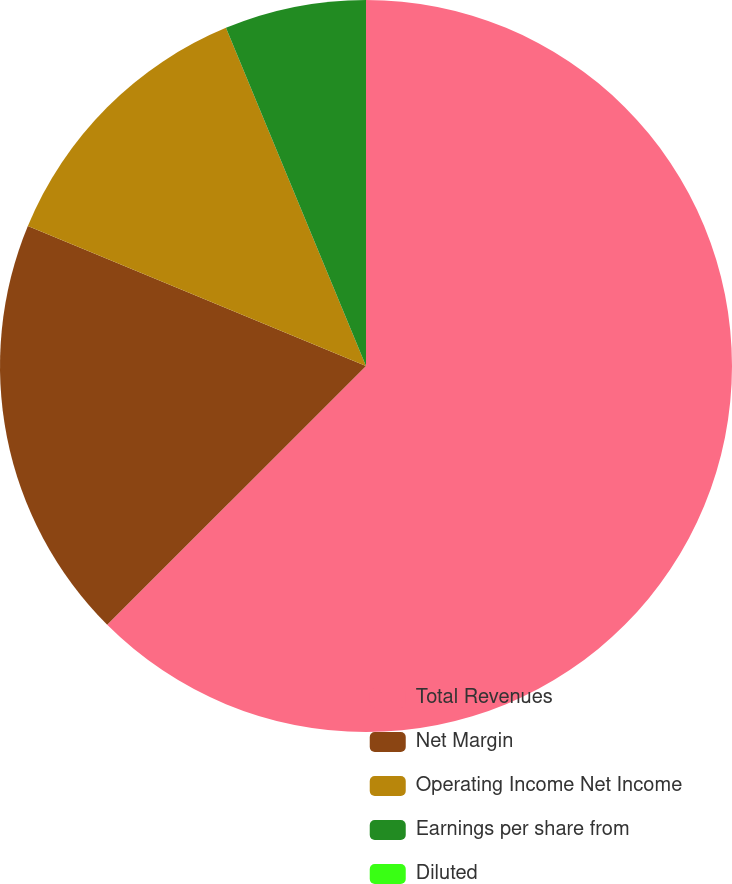<chart> <loc_0><loc_0><loc_500><loc_500><pie_chart><fcel>Total Revenues<fcel>Net Margin<fcel>Operating Income Net Income<fcel>Earnings per share from<fcel>Diluted<nl><fcel>62.5%<fcel>18.75%<fcel>12.5%<fcel>6.25%<fcel>0.0%<nl></chart> 